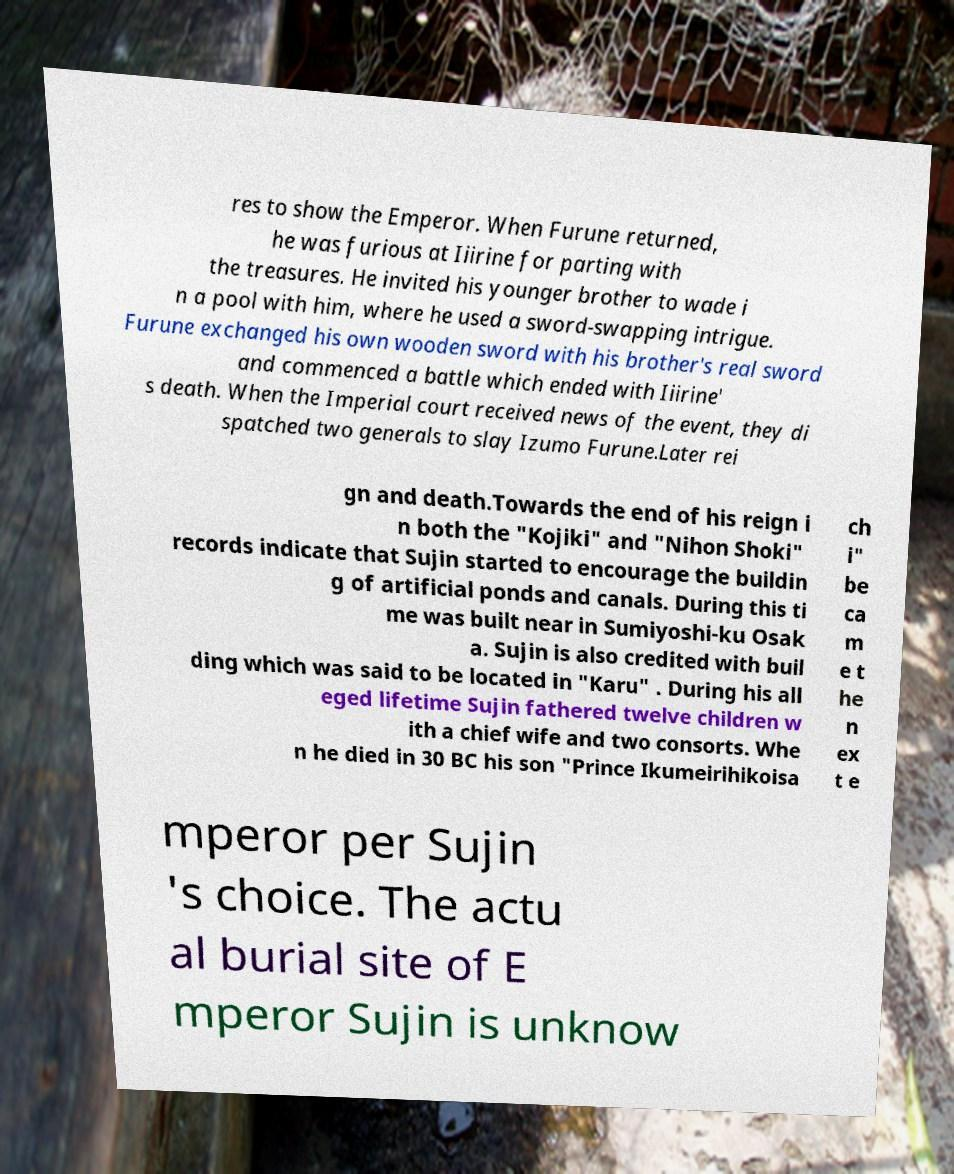Could you assist in decoding the text presented in this image and type it out clearly? res to show the Emperor. When Furune returned, he was furious at Iiirine for parting with the treasures. He invited his younger brother to wade i n a pool with him, where he used a sword-swapping intrigue. Furune exchanged his own wooden sword with his brother's real sword and commenced a battle which ended with Iiirine' s death. When the Imperial court received news of the event, they di spatched two generals to slay Izumo Furune.Later rei gn and death.Towards the end of his reign i n both the "Kojiki" and "Nihon Shoki" records indicate that Sujin started to encourage the buildin g of artificial ponds and canals. During this ti me was built near in Sumiyoshi-ku Osak a. Sujin is also credited with buil ding which was said to be located in "Karu" . During his all eged lifetime Sujin fathered twelve children w ith a chief wife and two consorts. Whe n he died in 30 BC his son "Prince Ikumeirihikoisa ch i" be ca m e t he n ex t e mperor per Sujin 's choice. The actu al burial site of E mperor Sujin is unknow 